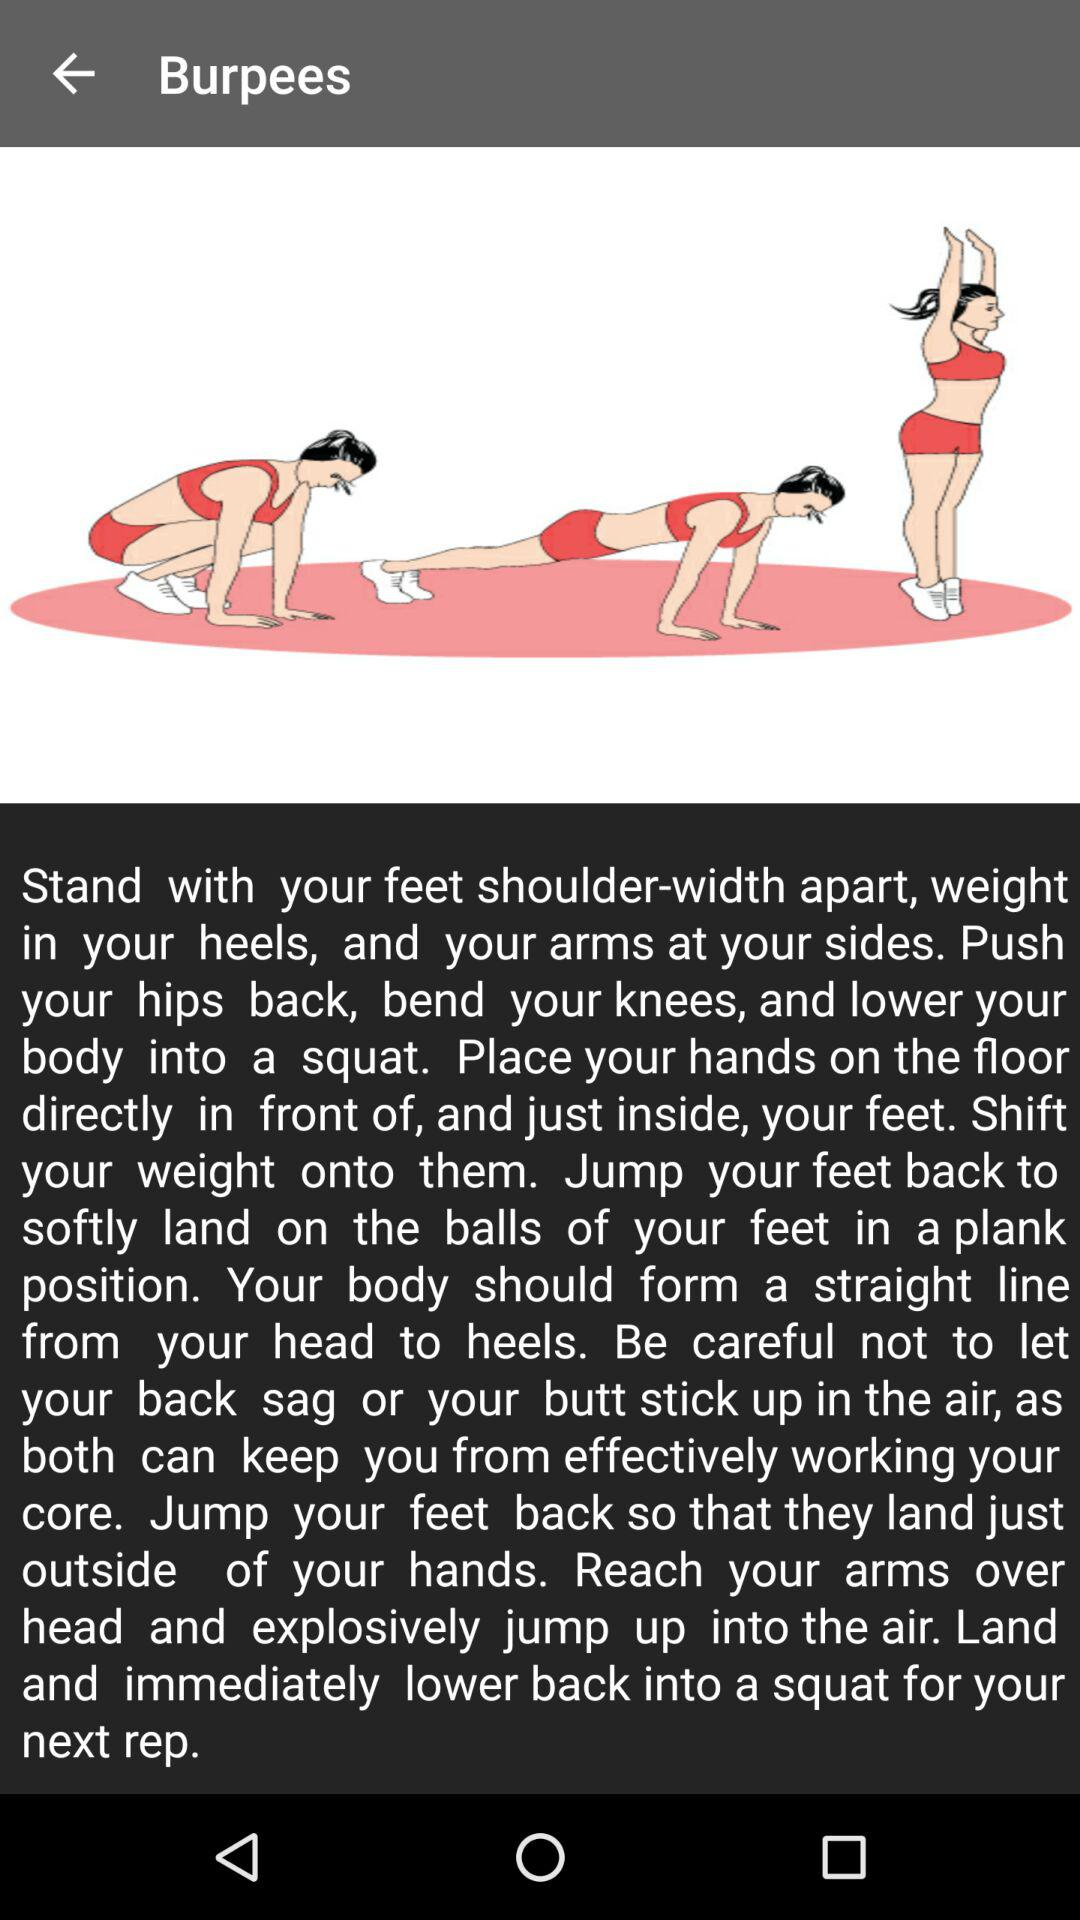What is the application name?
When the provided information is insufficient, respond with <no answer>. <no answer> 